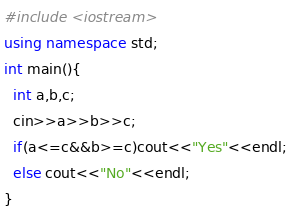<code> <loc_0><loc_0><loc_500><loc_500><_C++_>#include <iostream>
using namespace std;
int main(){
  int a,b,c;
  cin>>a>>b>>c;
  if(a<=c&&b>=c)cout<<"Yes"<<endl;
  else cout<<"No"<<endl;
}</code> 